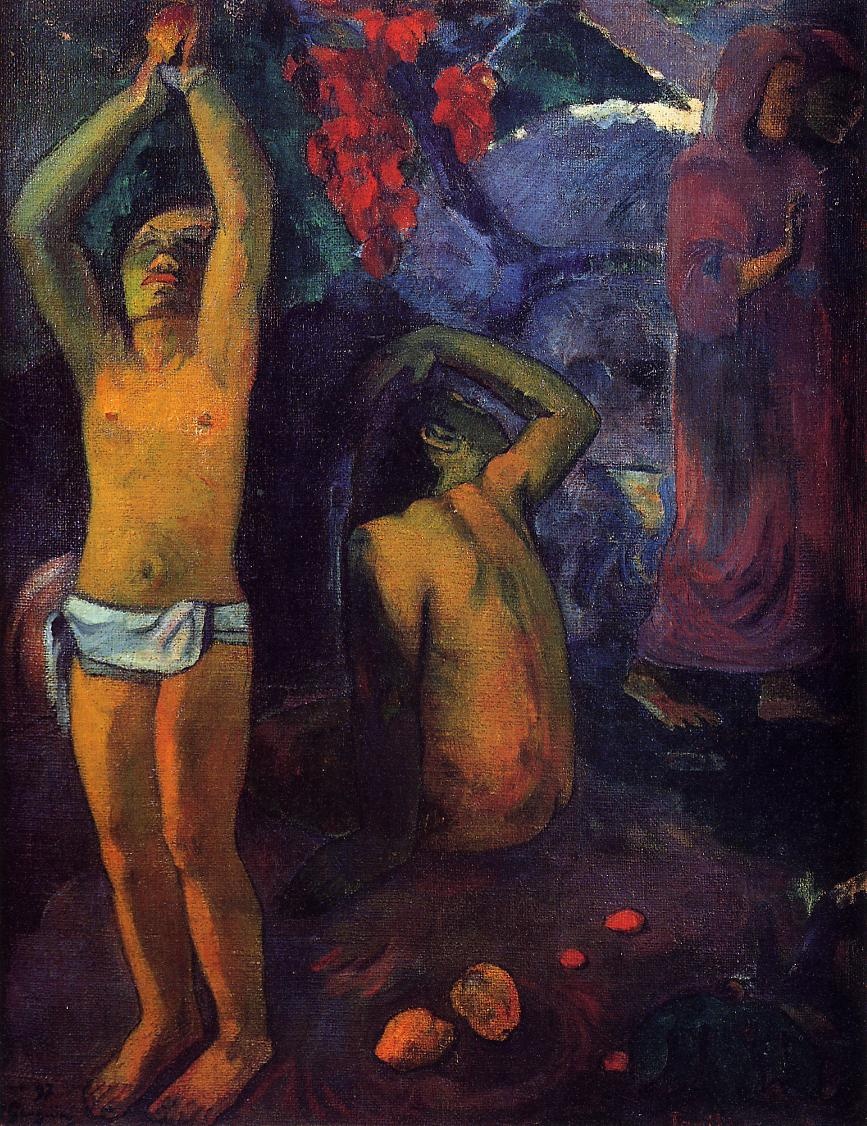What might be the symbolic meaning behind the central figure's gesture with raised arms? The gesture of the central figure with raised arms in Gauguin's painting can imply multiple meanings. It might represent a questioning of the cosmos or a spiritual exclamation, reaching out to the divine or the universe for answers. The openness and vulnerability of the pose also suggest a surrender or a deep existential inquiry, pivotal to the painting's overarching themes about life's purpose and human existence. 